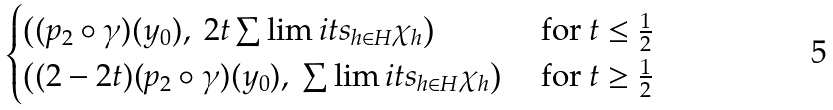<formula> <loc_0><loc_0><loc_500><loc_500>\begin{cases} \left ( ( p _ { 2 } \circ \gamma ) ( y _ { 0 } ) , \ 2 t \sum \lim i t s _ { h \in H } \chi _ { h } \right ) & \text {  for } t \leq \frac { 1 } { 2 } \\ \left ( ( 2 - 2 t ) ( p _ { 2 } \circ \gamma ) ( y _ { 0 } ) , \ \sum \lim i t s _ { h \in H } \chi _ { h } \right ) & \text {  for } t \geq \frac { 1 } { 2 } \end{cases}</formula> 